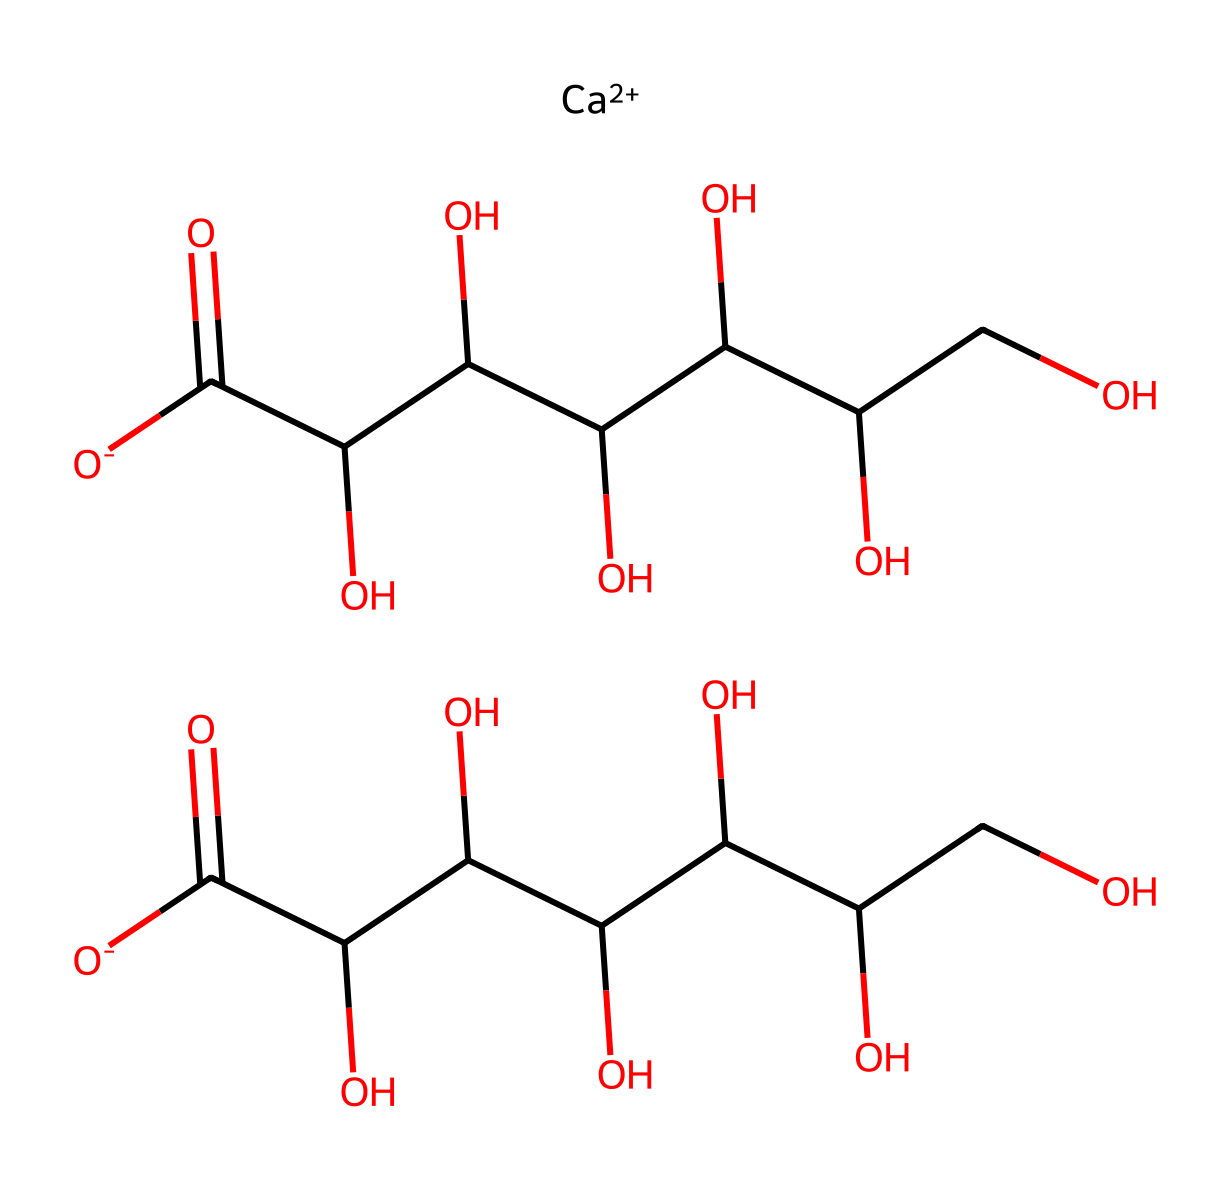What is the molecular formula of calcium gluconate? By analyzing the SMILES representation, we can identify the components of the molecule. The [Ca++] indicates the presence of a calcium ion, while the other portions represent gluconate, which contains carbon, hydrogen, and oxygen atoms. Counting the elements gives us the molecular formula: C12H22CaO14.
Answer: C12H22CaO14 How many carbon atoms are present in calcium gluconate? In the chemical structure expressed through SMILES, the carbon atoms are represented in the backbone of the gluconate structure. Counting the 'C' characters yields a total of 12 carbon atoms.
Answer: 12 What type of compound is calcium gluconate? Calcium gluconate is classified as an electrolyte as it dissociates into calcium ions and gluconate ions in solution, facilitating electrical conduction. This property is typically associated with electrolyte compounds.
Answer: electrolyte How many hydroxyl (OH) groups are in calcium gluconate? The structure of calcium gluconate includes multiple hydroxyl groups, which are typically represented by 'C(O)' in the SMILES notation. By counting these segments, you can identify there are 6 hydroxyl groups.
Answer: 6 What role does calcium play in calcium gluconate? Calcium, as denoted by [Ca++] in the SMILES notation, contributes to bone strengthening by providing essential calcium ions, which are integral for bone structure and health. This is a key function of calcium in supplements.
Answer: bone strengthening 